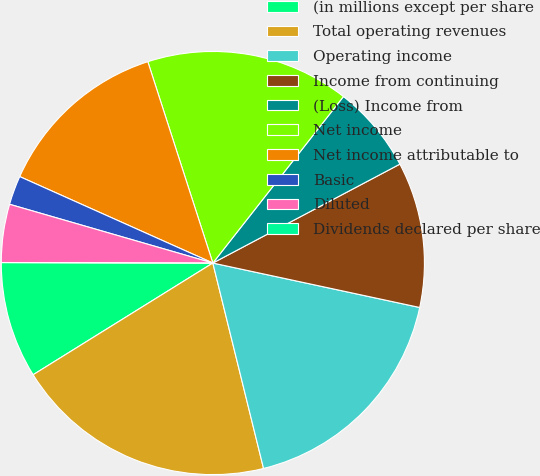<chart> <loc_0><loc_0><loc_500><loc_500><pie_chart><fcel>(in millions except per share<fcel>Total operating revenues<fcel>Operating income<fcel>Income from continuing<fcel>(Loss) Income from<fcel>Net income<fcel>Net income attributable to<fcel>Basic<fcel>Diluted<fcel>Dividends declared per share<nl><fcel>8.89%<fcel>20.0%<fcel>17.78%<fcel>11.11%<fcel>6.67%<fcel>15.56%<fcel>13.33%<fcel>2.22%<fcel>4.44%<fcel>0.0%<nl></chart> 